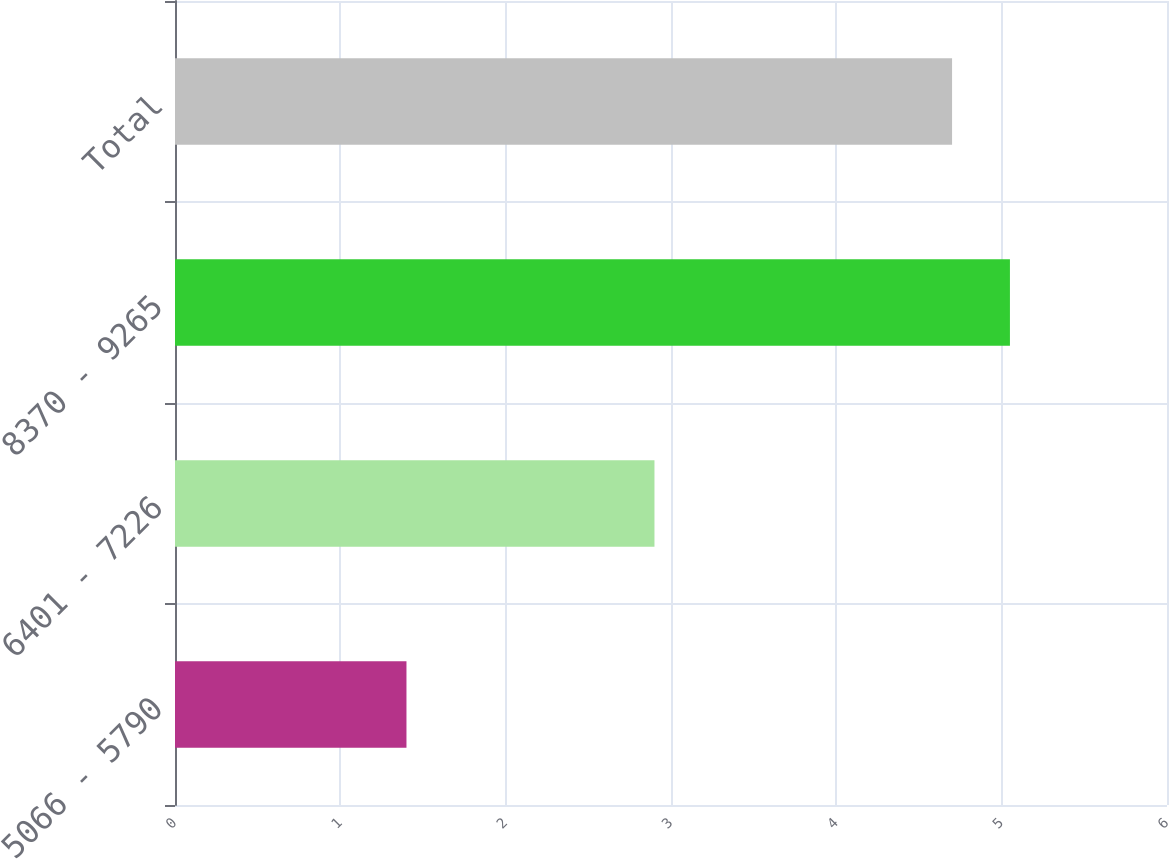Convert chart to OTSL. <chart><loc_0><loc_0><loc_500><loc_500><bar_chart><fcel>5066 - 5790<fcel>6401 - 7226<fcel>8370 - 9265<fcel>Total<nl><fcel>1.4<fcel>2.9<fcel>5.05<fcel>4.7<nl></chart> 